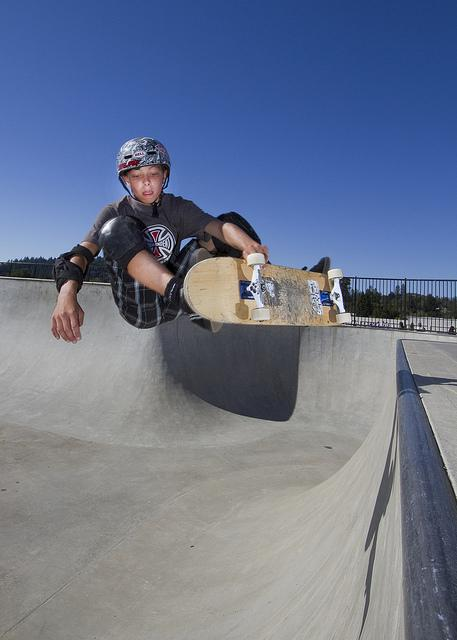Why is his head covered?

Choices:
A) fashion
B) religion
C) protection
D) warmth protection 